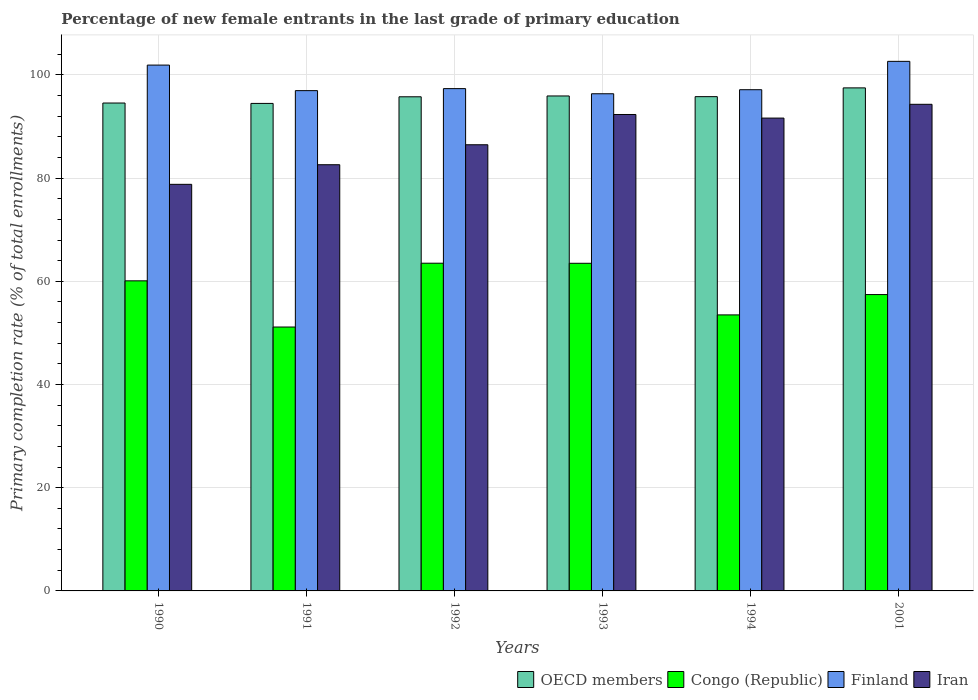Are the number of bars on each tick of the X-axis equal?
Provide a succinct answer. Yes. How many bars are there on the 5th tick from the right?
Ensure brevity in your answer.  4. In how many cases, is the number of bars for a given year not equal to the number of legend labels?
Provide a succinct answer. 0. What is the percentage of new female entrants in Finland in 1994?
Ensure brevity in your answer.  97.13. Across all years, what is the maximum percentage of new female entrants in Congo (Republic)?
Offer a terse response. 63.51. Across all years, what is the minimum percentage of new female entrants in Congo (Republic)?
Offer a very short reply. 51.14. What is the total percentage of new female entrants in OECD members in the graph?
Make the answer very short. 573.97. What is the difference between the percentage of new female entrants in Iran in 1990 and that in 1992?
Make the answer very short. -7.67. What is the difference between the percentage of new female entrants in Finland in 1993 and the percentage of new female entrants in Iran in 1991?
Make the answer very short. 13.75. What is the average percentage of new female entrants in Congo (Republic) per year?
Your answer should be very brief. 58.19. In the year 1991, what is the difference between the percentage of new female entrants in Iran and percentage of new female entrants in Congo (Republic)?
Keep it short and to the point. 31.45. What is the ratio of the percentage of new female entrants in Congo (Republic) in 1991 to that in 1993?
Ensure brevity in your answer.  0.81. Is the difference between the percentage of new female entrants in Iran in 1992 and 2001 greater than the difference between the percentage of new female entrants in Congo (Republic) in 1992 and 2001?
Ensure brevity in your answer.  No. What is the difference between the highest and the second highest percentage of new female entrants in Congo (Republic)?
Provide a succinct answer. 0.02. What is the difference between the highest and the lowest percentage of new female entrants in Congo (Republic)?
Keep it short and to the point. 12.36. Is the sum of the percentage of new female entrants in Finland in 1990 and 1994 greater than the maximum percentage of new female entrants in Congo (Republic) across all years?
Keep it short and to the point. Yes. What does the 2nd bar from the right in 1990 represents?
Make the answer very short. Finland. Are all the bars in the graph horizontal?
Your answer should be very brief. No. How many years are there in the graph?
Offer a terse response. 6. What is the difference between two consecutive major ticks on the Y-axis?
Your response must be concise. 20. Are the values on the major ticks of Y-axis written in scientific E-notation?
Provide a short and direct response. No. Does the graph contain any zero values?
Provide a succinct answer. No. Where does the legend appear in the graph?
Provide a succinct answer. Bottom right. How are the legend labels stacked?
Make the answer very short. Horizontal. What is the title of the graph?
Your answer should be compact. Percentage of new female entrants in the last grade of primary education. What is the label or title of the Y-axis?
Offer a terse response. Primary completion rate (% of total enrollments). What is the Primary completion rate (% of total enrollments) of OECD members in 1990?
Your response must be concise. 94.55. What is the Primary completion rate (% of total enrollments) in Congo (Republic) in 1990?
Your answer should be very brief. 60.09. What is the Primary completion rate (% of total enrollments) in Finland in 1990?
Ensure brevity in your answer.  101.9. What is the Primary completion rate (% of total enrollments) in Iran in 1990?
Your response must be concise. 78.79. What is the Primary completion rate (% of total enrollments) in OECD members in 1991?
Provide a succinct answer. 94.47. What is the Primary completion rate (% of total enrollments) of Congo (Republic) in 1991?
Provide a short and direct response. 51.14. What is the Primary completion rate (% of total enrollments) of Finland in 1991?
Offer a very short reply. 96.95. What is the Primary completion rate (% of total enrollments) in Iran in 1991?
Offer a very short reply. 82.59. What is the Primary completion rate (% of total enrollments) in OECD members in 1992?
Provide a succinct answer. 95.76. What is the Primary completion rate (% of total enrollments) in Congo (Republic) in 1992?
Your answer should be very brief. 63.51. What is the Primary completion rate (% of total enrollments) in Finland in 1992?
Your answer should be compact. 97.34. What is the Primary completion rate (% of total enrollments) in Iran in 1992?
Provide a short and direct response. 86.46. What is the Primary completion rate (% of total enrollments) of OECD members in 1993?
Your answer should be very brief. 95.92. What is the Primary completion rate (% of total enrollments) in Congo (Republic) in 1993?
Provide a succinct answer. 63.49. What is the Primary completion rate (% of total enrollments) in Finland in 1993?
Your answer should be very brief. 96.35. What is the Primary completion rate (% of total enrollments) of Iran in 1993?
Give a very brief answer. 92.33. What is the Primary completion rate (% of total enrollments) of OECD members in 1994?
Make the answer very short. 95.79. What is the Primary completion rate (% of total enrollments) in Congo (Republic) in 1994?
Offer a terse response. 53.49. What is the Primary completion rate (% of total enrollments) of Finland in 1994?
Your answer should be compact. 97.13. What is the Primary completion rate (% of total enrollments) of Iran in 1994?
Your answer should be very brief. 91.63. What is the Primary completion rate (% of total enrollments) in OECD members in 2001?
Offer a terse response. 97.48. What is the Primary completion rate (% of total enrollments) of Congo (Republic) in 2001?
Provide a succinct answer. 57.43. What is the Primary completion rate (% of total enrollments) in Finland in 2001?
Make the answer very short. 102.62. What is the Primary completion rate (% of total enrollments) of Iran in 2001?
Keep it short and to the point. 94.3. Across all years, what is the maximum Primary completion rate (% of total enrollments) of OECD members?
Make the answer very short. 97.48. Across all years, what is the maximum Primary completion rate (% of total enrollments) in Congo (Republic)?
Your answer should be very brief. 63.51. Across all years, what is the maximum Primary completion rate (% of total enrollments) of Finland?
Provide a short and direct response. 102.62. Across all years, what is the maximum Primary completion rate (% of total enrollments) in Iran?
Offer a terse response. 94.3. Across all years, what is the minimum Primary completion rate (% of total enrollments) in OECD members?
Keep it short and to the point. 94.47. Across all years, what is the minimum Primary completion rate (% of total enrollments) in Congo (Republic)?
Provide a succinct answer. 51.14. Across all years, what is the minimum Primary completion rate (% of total enrollments) of Finland?
Provide a short and direct response. 96.35. Across all years, what is the minimum Primary completion rate (% of total enrollments) in Iran?
Give a very brief answer. 78.79. What is the total Primary completion rate (% of total enrollments) of OECD members in the graph?
Your answer should be compact. 573.97. What is the total Primary completion rate (% of total enrollments) of Congo (Republic) in the graph?
Provide a succinct answer. 349.15. What is the total Primary completion rate (% of total enrollments) in Finland in the graph?
Give a very brief answer. 592.29. What is the total Primary completion rate (% of total enrollments) of Iran in the graph?
Provide a succinct answer. 526.11. What is the difference between the Primary completion rate (% of total enrollments) in OECD members in 1990 and that in 1991?
Keep it short and to the point. 0.08. What is the difference between the Primary completion rate (% of total enrollments) in Congo (Republic) in 1990 and that in 1991?
Your response must be concise. 8.95. What is the difference between the Primary completion rate (% of total enrollments) of Finland in 1990 and that in 1991?
Keep it short and to the point. 4.95. What is the difference between the Primary completion rate (% of total enrollments) in Iran in 1990 and that in 1991?
Provide a succinct answer. -3.8. What is the difference between the Primary completion rate (% of total enrollments) of OECD members in 1990 and that in 1992?
Ensure brevity in your answer.  -1.21. What is the difference between the Primary completion rate (% of total enrollments) in Congo (Republic) in 1990 and that in 1992?
Your answer should be compact. -3.41. What is the difference between the Primary completion rate (% of total enrollments) in Finland in 1990 and that in 1992?
Provide a short and direct response. 4.56. What is the difference between the Primary completion rate (% of total enrollments) of Iran in 1990 and that in 1992?
Make the answer very short. -7.67. What is the difference between the Primary completion rate (% of total enrollments) of OECD members in 1990 and that in 1993?
Provide a short and direct response. -1.37. What is the difference between the Primary completion rate (% of total enrollments) in Congo (Republic) in 1990 and that in 1993?
Ensure brevity in your answer.  -3.4. What is the difference between the Primary completion rate (% of total enrollments) of Finland in 1990 and that in 1993?
Offer a terse response. 5.56. What is the difference between the Primary completion rate (% of total enrollments) of Iran in 1990 and that in 1993?
Make the answer very short. -13.53. What is the difference between the Primary completion rate (% of total enrollments) of OECD members in 1990 and that in 1994?
Your answer should be very brief. -1.24. What is the difference between the Primary completion rate (% of total enrollments) of Congo (Republic) in 1990 and that in 1994?
Provide a short and direct response. 6.6. What is the difference between the Primary completion rate (% of total enrollments) of Finland in 1990 and that in 1994?
Provide a succinct answer. 4.77. What is the difference between the Primary completion rate (% of total enrollments) of Iran in 1990 and that in 1994?
Provide a succinct answer. -12.84. What is the difference between the Primary completion rate (% of total enrollments) in OECD members in 1990 and that in 2001?
Offer a terse response. -2.93. What is the difference between the Primary completion rate (% of total enrollments) of Congo (Republic) in 1990 and that in 2001?
Make the answer very short. 2.66. What is the difference between the Primary completion rate (% of total enrollments) in Finland in 1990 and that in 2001?
Your response must be concise. -0.72. What is the difference between the Primary completion rate (% of total enrollments) of Iran in 1990 and that in 2001?
Provide a succinct answer. -15.51. What is the difference between the Primary completion rate (% of total enrollments) of OECD members in 1991 and that in 1992?
Your response must be concise. -1.28. What is the difference between the Primary completion rate (% of total enrollments) in Congo (Republic) in 1991 and that in 1992?
Offer a terse response. -12.36. What is the difference between the Primary completion rate (% of total enrollments) in Finland in 1991 and that in 1992?
Ensure brevity in your answer.  -0.39. What is the difference between the Primary completion rate (% of total enrollments) in Iran in 1991 and that in 1992?
Keep it short and to the point. -3.87. What is the difference between the Primary completion rate (% of total enrollments) of OECD members in 1991 and that in 1993?
Make the answer very short. -1.44. What is the difference between the Primary completion rate (% of total enrollments) in Congo (Republic) in 1991 and that in 1993?
Give a very brief answer. -12.35. What is the difference between the Primary completion rate (% of total enrollments) of Finland in 1991 and that in 1993?
Provide a succinct answer. 0.6. What is the difference between the Primary completion rate (% of total enrollments) in Iran in 1991 and that in 1993?
Your answer should be very brief. -9.74. What is the difference between the Primary completion rate (% of total enrollments) of OECD members in 1991 and that in 1994?
Your answer should be very brief. -1.31. What is the difference between the Primary completion rate (% of total enrollments) in Congo (Republic) in 1991 and that in 1994?
Make the answer very short. -2.35. What is the difference between the Primary completion rate (% of total enrollments) of Finland in 1991 and that in 1994?
Your answer should be compact. -0.18. What is the difference between the Primary completion rate (% of total enrollments) in Iran in 1991 and that in 1994?
Keep it short and to the point. -9.04. What is the difference between the Primary completion rate (% of total enrollments) in OECD members in 1991 and that in 2001?
Your answer should be very brief. -3.01. What is the difference between the Primary completion rate (% of total enrollments) of Congo (Republic) in 1991 and that in 2001?
Offer a terse response. -6.29. What is the difference between the Primary completion rate (% of total enrollments) of Finland in 1991 and that in 2001?
Offer a terse response. -5.67. What is the difference between the Primary completion rate (% of total enrollments) in Iran in 1991 and that in 2001?
Your answer should be compact. -11.71. What is the difference between the Primary completion rate (% of total enrollments) of OECD members in 1992 and that in 1993?
Keep it short and to the point. -0.16. What is the difference between the Primary completion rate (% of total enrollments) of Congo (Republic) in 1992 and that in 1993?
Ensure brevity in your answer.  0.02. What is the difference between the Primary completion rate (% of total enrollments) of Finland in 1992 and that in 1993?
Give a very brief answer. 0.99. What is the difference between the Primary completion rate (% of total enrollments) of Iran in 1992 and that in 1993?
Offer a terse response. -5.87. What is the difference between the Primary completion rate (% of total enrollments) of OECD members in 1992 and that in 1994?
Your response must be concise. -0.03. What is the difference between the Primary completion rate (% of total enrollments) in Congo (Republic) in 1992 and that in 1994?
Keep it short and to the point. 10.02. What is the difference between the Primary completion rate (% of total enrollments) in Finland in 1992 and that in 1994?
Offer a terse response. 0.21. What is the difference between the Primary completion rate (% of total enrollments) of Iran in 1992 and that in 1994?
Offer a very short reply. -5.17. What is the difference between the Primary completion rate (% of total enrollments) of OECD members in 1992 and that in 2001?
Provide a short and direct response. -1.73. What is the difference between the Primary completion rate (% of total enrollments) in Congo (Republic) in 1992 and that in 2001?
Keep it short and to the point. 6.07. What is the difference between the Primary completion rate (% of total enrollments) of Finland in 1992 and that in 2001?
Make the answer very short. -5.28. What is the difference between the Primary completion rate (% of total enrollments) in Iran in 1992 and that in 2001?
Ensure brevity in your answer.  -7.84. What is the difference between the Primary completion rate (% of total enrollments) in OECD members in 1993 and that in 1994?
Give a very brief answer. 0.13. What is the difference between the Primary completion rate (% of total enrollments) in Congo (Republic) in 1993 and that in 1994?
Provide a succinct answer. 10. What is the difference between the Primary completion rate (% of total enrollments) of Finland in 1993 and that in 1994?
Keep it short and to the point. -0.78. What is the difference between the Primary completion rate (% of total enrollments) of Iran in 1993 and that in 1994?
Offer a very short reply. 0.7. What is the difference between the Primary completion rate (% of total enrollments) in OECD members in 1993 and that in 2001?
Your response must be concise. -1.57. What is the difference between the Primary completion rate (% of total enrollments) in Congo (Republic) in 1993 and that in 2001?
Give a very brief answer. 6.06. What is the difference between the Primary completion rate (% of total enrollments) of Finland in 1993 and that in 2001?
Your answer should be very brief. -6.28. What is the difference between the Primary completion rate (% of total enrollments) of Iran in 1993 and that in 2001?
Make the answer very short. -1.97. What is the difference between the Primary completion rate (% of total enrollments) of OECD members in 1994 and that in 2001?
Your answer should be very brief. -1.7. What is the difference between the Primary completion rate (% of total enrollments) of Congo (Republic) in 1994 and that in 2001?
Give a very brief answer. -3.94. What is the difference between the Primary completion rate (% of total enrollments) of Finland in 1994 and that in 2001?
Your response must be concise. -5.5. What is the difference between the Primary completion rate (% of total enrollments) in Iran in 1994 and that in 2001?
Provide a succinct answer. -2.67. What is the difference between the Primary completion rate (% of total enrollments) of OECD members in 1990 and the Primary completion rate (% of total enrollments) of Congo (Republic) in 1991?
Your response must be concise. 43.41. What is the difference between the Primary completion rate (% of total enrollments) in OECD members in 1990 and the Primary completion rate (% of total enrollments) in Finland in 1991?
Your answer should be very brief. -2.4. What is the difference between the Primary completion rate (% of total enrollments) of OECD members in 1990 and the Primary completion rate (% of total enrollments) of Iran in 1991?
Your answer should be compact. 11.96. What is the difference between the Primary completion rate (% of total enrollments) in Congo (Republic) in 1990 and the Primary completion rate (% of total enrollments) in Finland in 1991?
Offer a terse response. -36.86. What is the difference between the Primary completion rate (% of total enrollments) of Congo (Republic) in 1990 and the Primary completion rate (% of total enrollments) of Iran in 1991?
Offer a terse response. -22.5. What is the difference between the Primary completion rate (% of total enrollments) in Finland in 1990 and the Primary completion rate (% of total enrollments) in Iran in 1991?
Keep it short and to the point. 19.31. What is the difference between the Primary completion rate (% of total enrollments) of OECD members in 1990 and the Primary completion rate (% of total enrollments) of Congo (Republic) in 1992?
Provide a short and direct response. 31.04. What is the difference between the Primary completion rate (% of total enrollments) in OECD members in 1990 and the Primary completion rate (% of total enrollments) in Finland in 1992?
Provide a short and direct response. -2.79. What is the difference between the Primary completion rate (% of total enrollments) of OECD members in 1990 and the Primary completion rate (% of total enrollments) of Iran in 1992?
Your answer should be compact. 8.09. What is the difference between the Primary completion rate (% of total enrollments) in Congo (Republic) in 1990 and the Primary completion rate (% of total enrollments) in Finland in 1992?
Offer a terse response. -37.25. What is the difference between the Primary completion rate (% of total enrollments) of Congo (Republic) in 1990 and the Primary completion rate (% of total enrollments) of Iran in 1992?
Keep it short and to the point. -26.37. What is the difference between the Primary completion rate (% of total enrollments) in Finland in 1990 and the Primary completion rate (% of total enrollments) in Iran in 1992?
Offer a terse response. 15.44. What is the difference between the Primary completion rate (% of total enrollments) in OECD members in 1990 and the Primary completion rate (% of total enrollments) in Congo (Republic) in 1993?
Keep it short and to the point. 31.06. What is the difference between the Primary completion rate (% of total enrollments) in OECD members in 1990 and the Primary completion rate (% of total enrollments) in Finland in 1993?
Offer a very short reply. -1.8. What is the difference between the Primary completion rate (% of total enrollments) in OECD members in 1990 and the Primary completion rate (% of total enrollments) in Iran in 1993?
Your answer should be very brief. 2.22. What is the difference between the Primary completion rate (% of total enrollments) of Congo (Republic) in 1990 and the Primary completion rate (% of total enrollments) of Finland in 1993?
Make the answer very short. -36.26. What is the difference between the Primary completion rate (% of total enrollments) of Congo (Republic) in 1990 and the Primary completion rate (% of total enrollments) of Iran in 1993?
Your response must be concise. -32.24. What is the difference between the Primary completion rate (% of total enrollments) in Finland in 1990 and the Primary completion rate (% of total enrollments) in Iran in 1993?
Your response must be concise. 9.57. What is the difference between the Primary completion rate (% of total enrollments) of OECD members in 1990 and the Primary completion rate (% of total enrollments) of Congo (Republic) in 1994?
Keep it short and to the point. 41.06. What is the difference between the Primary completion rate (% of total enrollments) in OECD members in 1990 and the Primary completion rate (% of total enrollments) in Finland in 1994?
Your response must be concise. -2.58. What is the difference between the Primary completion rate (% of total enrollments) of OECD members in 1990 and the Primary completion rate (% of total enrollments) of Iran in 1994?
Your answer should be very brief. 2.92. What is the difference between the Primary completion rate (% of total enrollments) of Congo (Republic) in 1990 and the Primary completion rate (% of total enrollments) of Finland in 1994?
Provide a succinct answer. -37.04. What is the difference between the Primary completion rate (% of total enrollments) in Congo (Republic) in 1990 and the Primary completion rate (% of total enrollments) in Iran in 1994?
Offer a terse response. -31.54. What is the difference between the Primary completion rate (% of total enrollments) of Finland in 1990 and the Primary completion rate (% of total enrollments) of Iran in 1994?
Give a very brief answer. 10.27. What is the difference between the Primary completion rate (% of total enrollments) of OECD members in 1990 and the Primary completion rate (% of total enrollments) of Congo (Republic) in 2001?
Offer a very short reply. 37.12. What is the difference between the Primary completion rate (% of total enrollments) of OECD members in 1990 and the Primary completion rate (% of total enrollments) of Finland in 2001?
Ensure brevity in your answer.  -8.07. What is the difference between the Primary completion rate (% of total enrollments) in OECD members in 1990 and the Primary completion rate (% of total enrollments) in Iran in 2001?
Your answer should be compact. 0.25. What is the difference between the Primary completion rate (% of total enrollments) in Congo (Republic) in 1990 and the Primary completion rate (% of total enrollments) in Finland in 2001?
Give a very brief answer. -42.53. What is the difference between the Primary completion rate (% of total enrollments) of Congo (Republic) in 1990 and the Primary completion rate (% of total enrollments) of Iran in 2001?
Your response must be concise. -34.21. What is the difference between the Primary completion rate (% of total enrollments) in Finland in 1990 and the Primary completion rate (% of total enrollments) in Iran in 2001?
Offer a terse response. 7.6. What is the difference between the Primary completion rate (% of total enrollments) of OECD members in 1991 and the Primary completion rate (% of total enrollments) of Congo (Republic) in 1992?
Make the answer very short. 30.97. What is the difference between the Primary completion rate (% of total enrollments) of OECD members in 1991 and the Primary completion rate (% of total enrollments) of Finland in 1992?
Provide a short and direct response. -2.87. What is the difference between the Primary completion rate (% of total enrollments) in OECD members in 1991 and the Primary completion rate (% of total enrollments) in Iran in 1992?
Ensure brevity in your answer.  8.01. What is the difference between the Primary completion rate (% of total enrollments) in Congo (Republic) in 1991 and the Primary completion rate (% of total enrollments) in Finland in 1992?
Your response must be concise. -46.2. What is the difference between the Primary completion rate (% of total enrollments) of Congo (Republic) in 1991 and the Primary completion rate (% of total enrollments) of Iran in 1992?
Provide a short and direct response. -35.32. What is the difference between the Primary completion rate (% of total enrollments) in Finland in 1991 and the Primary completion rate (% of total enrollments) in Iran in 1992?
Your answer should be compact. 10.49. What is the difference between the Primary completion rate (% of total enrollments) of OECD members in 1991 and the Primary completion rate (% of total enrollments) of Congo (Republic) in 1993?
Ensure brevity in your answer.  30.98. What is the difference between the Primary completion rate (% of total enrollments) of OECD members in 1991 and the Primary completion rate (% of total enrollments) of Finland in 1993?
Give a very brief answer. -1.87. What is the difference between the Primary completion rate (% of total enrollments) of OECD members in 1991 and the Primary completion rate (% of total enrollments) of Iran in 1993?
Give a very brief answer. 2.14. What is the difference between the Primary completion rate (% of total enrollments) in Congo (Republic) in 1991 and the Primary completion rate (% of total enrollments) in Finland in 1993?
Provide a succinct answer. -45.2. What is the difference between the Primary completion rate (% of total enrollments) in Congo (Republic) in 1991 and the Primary completion rate (% of total enrollments) in Iran in 1993?
Your response must be concise. -41.19. What is the difference between the Primary completion rate (% of total enrollments) in Finland in 1991 and the Primary completion rate (% of total enrollments) in Iran in 1993?
Offer a terse response. 4.62. What is the difference between the Primary completion rate (% of total enrollments) in OECD members in 1991 and the Primary completion rate (% of total enrollments) in Congo (Republic) in 1994?
Your answer should be compact. 40.98. What is the difference between the Primary completion rate (% of total enrollments) in OECD members in 1991 and the Primary completion rate (% of total enrollments) in Finland in 1994?
Your answer should be very brief. -2.66. What is the difference between the Primary completion rate (% of total enrollments) of OECD members in 1991 and the Primary completion rate (% of total enrollments) of Iran in 1994?
Ensure brevity in your answer.  2.84. What is the difference between the Primary completion rate (% of total enrollments) in Congo (Republic) in 1991 and the Primary completion rate (% of total enrollments) in Finland in 1994?
Your answer should be compact. -45.99. What is the difference between the Primary completion rate (% of total enrollments) of Congo (Republic) in 1991 and the Primary completion rate (% of total enrollments) of Iran in 1994?
Keep it short and to the point. -40.49. What is the difference between the Primary completion rate (% of total enrollments) in Finland in 1991 and the Primary completion rate (% of total enrollments) in Iran in 1994?
Your response must be concise. 5.32. What is the difference between the Primary completion rate (% of total enrollments) of OECD members in 1991 and the Primary completion rate (% of total enrollments) of Congo (Republic) in 2001?
Your answer should be very brief. 37.04. What is the difference between the Primary completion rate (% of total enrollments) in OECD members in 1991 and the Primary completion rate (% of total enrollments) in Finland in 2001?
Your answer should be compact. -8.15. What is the difference between the Primary completion rate (% of total enrollments) of OECD members in 1991 and the Primary completion rate (% of total enrollments) of Iran in 2001?
Keep it short and to the point. 0.17. What is the difference between the Primary completion rate (% of total enrollments) of Congo (Republic) in 1991 and the Primary completion rate (% of total enrollments) of Finland in 2001?
Provide a succinct answer. -51.48. What is the difference between the Primary completion rate (% of total enrollments) in Congo (Republic) in 1991 and the Primary completion rate (% of total enrollments) in Iran in 2001?
Keep it short and to the point. -43.16. What is the difference between the Primary completion rate (% of total enrollments) of Finland in 1991 and the Primary completion rate (% of total enrollments) of Iran in 2001?
Make the answer very short. 2.65. What is the difference between the Primary completion rate (% of total enrollments) in OECD members in 1992 and the Primary completion rate (% of total enrollments) in Congo (Republic) in 1993?
Give a very brief answer. 32.27. What is the difference between the Primary completion rate (% of total enrollments) of OECD members in 1992 and the Primary completion rate (% of total enrollments) of Finland in 1993?
Provide a short and direct response. -0.59. What is the difference between the Primary completion rate (% of total enrollments) in OECD members in 1992 and the Primary completion rate (% of total enrollments) in Iran in 1993?
Provide a succinct answer. 3.43. What is the difference between the Primary completion rate (% of total enrollments) in Congo (Republic) in 1992 and the Primary completion rate (% of total enrollments) in Finland in 1993?
Offer a terse response. -32.84. What is the difference between the Primary completion rate (% of total enrollments) in Congo (Republic) in 1992 and the Primary completion rate (% of total enrollments) in Iran in 1993?
Make the answer very short. -28.82. What is the difference between the Primary completion rate (% of total enrollments) of Finland in 1992 and the Primary completion rate (% of total enrollments) of Iran in 1993?
Make the answer very short. 5.01. What is the difference between the Primary completion rate (% of total enrollments) of OECD members in 1992 and the Primary completion rate (% of total enrollments) of Congo (Republic) in 1994?
Your answer should be compact. 42.27. What is the difference between the Primary completion rate (% of total enrollments) in OECD members in 1992 and the Primary completion rate (% of total enrollments) in Finland in 1994?
Make the answer very short. -1.37. What is the difference between the Primary completion rate (% of total enrollments) of OECD members in 1992 and the Primary completion rate (% of total enrollments) of Iran in 1994?
Offer a very short reply. 4.13. What is the difference between the Primary completion rate (% of total enrollments) in Congo (Republic) in 1992 and the Primary completion rate (% of total enrollments) in Finland in 1994?
Offer a very short reply. -33.62. What is the difference between the Primary completion rate (% of total enrollments) of Congo (Republic) in 1992 and the Primary completion rate (% of total enrollments) of Iran in 1994?
Your response must be concise. -28.12. What is the difference between the Primary completion rate (% of total enrollments) in Finland in 1992 and the Primary completion rate (% of total enrollments) in Iran in 1994?
Ensure brevity in your answer.  5.71. What is the difference between the Primary completion rate (% of total enrollments) in OECD members in 1992 and the Primary completion rate (% of total enrollments) in Congo (Republic) in 2001?
Make the answer very short. 38.33. What is the difference between the Primary completion rate (% of total enrollments) of OECD members in 1992 and the Primary completion rate (% of total enrollments) of Finland in 2001?
Keep it short and to the point. -6.87. What is the difference between the Primary completion rate (% of total enrollments) in OECD members in 1992 and the Primary completion rate (% of total enrollments) in Iran in 2001?
Make the answer very short. 1.45. What is the difference between the Primary completion rate (% of total enrollments) of Congo (Republic) in 1992 and the Primary completion rate (% of total enrollments) of Finland in 2001?
Provide a short and direct response. -39.12. What is the difference between the Primary completion rate (% of total enrollments) in Congo (Republic) in 1992 and the Primary completion rate (% of total enrollments) in Iran in 2001?
Provide a short and direct response. -30.8. What is the difference between the Primary completion rate (% of total enrollments) in Finland in 1992 and the Primary completion rate (% of total enrollments) in Iran in 2001?
Provide a succinct answer. 3.04. What is the difference between the Primary completion rate (% of total enrollments) in OECD members in 1993 and the Primary completion rate (% of total enrollments) in Congo (Republic) in 1994?
Ensure brevity in your answer.  42.43. What is the difference between the Primary completion rate (% of total enrollments) of OECD members in 1993 and the Primary completion rate (% of total enrollments) of Finland in 1994?
Your response must be concise. -1.21. What is the difference between the Primary completion rate (% of total enrollments) in OECD members in 1993 and the Primary completion rate (% of total enrollments) in Iran in 1994?
Your response must be concise. 4.29. What is the difference between the Primary completion rate (% of total enrollments) of Congo (Republic) in 1993 and the Primary completion rate (% of total enrollments) of Finland in 1994?
Provide a succinct answer. -33.64. What is the difference between the Primary completion rate (% of total enrollments) in Congo (Republic) in 1993 and the Primary completion rate (% of total enrollments) in Iran in 1994?
Your answer should be very brief. -28.14. What is the difference between the Primary completion rate (% of total enrollments) in Finland in 1993 and the Primary completion rate (% of total enrollments) in Iran in 1994?
Offer a very short reply. 4.72. What is the difference between the Primary completion rate (% of total enrollments) of OECD members in 1993 and the Primary completion rate (% of total enrollments) of Congo (Republic) in 2001?
Give a very brief answer. 38.49. What is the difference between the Primary completion rate (% of total enrollments) in OECD members in 1993 and the Primary completion rate (% of total enrollments) in Finland in 2001?
Your answer should be compact. -6.71. What is the difference between the Primary completion rate (% of total enrollments) in OECD members in 1993 and the Primary completion rate (% of total enrollments) in Iran in 2001?
Offer a terse response. 1.61. What is the difference between the Primary completion rate (% of total enrollments) of Congo (Republic) in 1993 and the Primary completion rate (% of total enrollments) of Finland in 2001?
Give a very brief answer. -39.13. What is the difference between the Primary completion rate (% of total enrollments) in Congo (Republic) in 1993 and the Primary completion rate (% of total enrollments) in Iran in 2001?
Make the answer very short. -30.81. What is the difference between the Primary completion rate (% of total enrollments) in Finland in 1993 and the Primary completion rate (% of total enrollments) in Iran in 2001?
Offer a terse response. 2.04. What is the difference between the Primary completion rate (% of total enrollments) of OECD members in 1994 and the Primary completion rate (% of total enrollments) of Congo (Republic) in 2001?
Provide a succinct answer. 38.35. What is the difference between the Primary completion rate (% of total enrollments) of OECD members in 1994 and the Primary completion rate (% of total enrollments) of Finland in 2001?
Your answer should be compact. -6.84. What is the difference between the Primary completion rate (% of total enrollments) of OECD members in 1994 and the Primary completion rate (% of total enrollments) of Iran in 2001?
Your answer should be compact. 1.48. What is the difference between the Primary completion rate (% of total enrollments) of Congo (Republic) in 1994 and the Primary completion rate (% of total enrollments) of Finland in 2001?
Your answer should be compact. -49.13. What is the difference between the Primary completion rate (% of total enrollments) of Congo (Republic) in 1994 and the Primary completion rate (% of total enrollments) of Iran in 2001?
Your response must be concise. -40.81. What is the difference between the Primary completion rate (% of total enrollments) of Finland in 1994 and the Primary completion rate (% of total enrollments) of Iran in 2001?
Keep it short and to the point. 2.83. What is the average Primary completion rate (% of total enrollments) of OECD members per year?
Provide a succinct answer. 95.66. What is the average Primary completion rate (% of total enrollments) of Congo (Republic) per year?
Your answer should be compact. 58.19. What is the average Primary completion rate (% of total enrollments) of Finland per year?
Give a very brief answer. 98.72. What is the average Primary completion rate (% of total enrollments) in Iran per year?
Provide a succinct answer. 87.69. In the year 1990, what is the difference between the Primary completion rate (% of total enrollments) in OECD members and Primary completion rate (% of total enrollments) in Congo (Republic)?
Ensure brevity in your answer.  34.46. In the year 1990, what is the difference between the Primary completion rate (% of total enrollments) in OECD members and Primary completion rate (% of total enrollments) in Finland?
Your answer should be compact. -7.35. In the year 1990, what is the difference between the Primary completion rate (% of total enrollments) of OECD members and Primary completion rate (% of total enrollments) of Iran?
Make the answer very short. 15.76. In the year 1990, what is the difference between the Primary completion rate (% of total enrollments) of Congo (Republic) and Primary completion rate (% of total enrollments) of Finland?
Provide a short and direct response. -41.81. In the year 1990, what is the difference between the Primary completion rate (% of total enrollments) in Congo (Republic) and Primary completion rate (% of total enrollments) in Iran?
Keep it short and to the point. -18.7. In the year 1990, what is the difference between the Primary completion rate (% of total enrollments) of Finland and Primary completion rate (% of total enrollments) of Iran?
Provide a short and direct response. 23.11. In the year 1991, what is the difference between the Primary completion rate (% of total enrollments) in OECD members and Primary completion rate (% of total enrollments) in Congo (Republic)?
Provide a succinct answer. 43.33. In the year 1991, what is the difference between the Primary completion rate (% of total enrollments) in OECD members and Primary completion rate (% of total enrollments) in Finland?
Your answer should be compact. -2.48. In the year 1991, what is the difference between the Primary completion rate (% of total enrollments) in OECD members and Primary completion rate (% of total enrollments) in Iran?
Give a very brief answer. 11.88. In the year 1991, what is the difference between the Primary completion rate (% of total enrollments) of Congo (Republic) and Primary completion rate (% of total enrollments) of Finland?
Provide a short and direct response. -45.81. In the year 1991, what is the difference between the Primary completion rate (% of total enrollments) of Congo (Republic) and Primary completion rate (% of total enrollments) of Iran?
Ensure brevity in your answer.  -31.45. In the year 1991, what is the difference between the Primary completion rate (% of total enrollments) in Finland and Primary completion rate (% of total enrollments) in Iran?
Your answer should be compact. 14.36. In the year 1992, what is the difference between the Primary completion rate (% of total enrollments) of OECD members and Primary completion rate (% of total enrollments) of Congo (Republic)?
Your answer should be very brief. 32.25. In the year 1992, what is the difference between the Primary completion rate (% of total enrollments) in OECD members and Primary completion rate (% of total enrollments) in Finland?
Your answer should be compact. -1.58. In the year 1992, what is the difference between the Primary completion rate (% of total enrollments) in OECD members and Primary completion rate (% of total enrollments) in Iran?
Offer a very short reply. 9.29. In the year 1992, what is the difference between the Primary completion rate (% of total enrollments) in Congo (Republic) and Primary completion rate (% of total enrollments) in Finland?
Make the answer very short. -33.83. In the year 1992, what is the difference between the Primary completion rate (% of total enrollments) in Congo (Republic) and Primary completion rate (% of total enrollments) in Iran?
Offer a very short reply. -22.96. In the year 1992, what is the difference between the Primary completion rate (% of total enrollments) in Finland and Primary completion rate (% of total enrollments) in Iran?
Your response must be concise. 10.88. In the year 1993, what is the difference between the Primary completion rate (% of total enrollments) in OECD members and Primary completion rate (% of total enrollments) in Congo (Republic)?
Your response must be concise. 32.43. In the year 1993, what is the difference between the Primary completion rate (% of total enrollments) of OECD members and Primary completion rate (% of total enrollments) of Finland?
Offer a very short reply. -0.43. In the year 1993, what is the difference between the Primary completion rate (% of total enrollments) in OECD members and Primary completion rate (% of total enrollments) in Iran?
Make the answer very short. 3.59. In the year 1993, what is the difference between the Primary completion rate (% of total enrollments) of Congo (Republic) and Primary completion rate (% of total enrollments) of Finland?
Ensure brevity in your answer.  -32.86. In the year 1993, what is the difference between the Primary completion rate (% of total enrollments) of Congo (Republic) and Primary completion rate (% of total enrollments) of Iran?
Keep it short and to the point. -28.84. In the year 1993, what is the difference between the Primary completion rate (% of total enrollments) of Finland and Primary completion rate (% of total enrollments) of Iran?
Make the answer very short. 4.02. In the year 1994, what is the difference between the Primary completion rate (% of total enrollments) of OECD members and Primary completion rate (% of total enrollments) of Congo (Republic)?
Your answer should be very brief. 42.3. In the year 1994, what is the difference between the Primary completion rate (% of total enrollments) in OECD members and Primary completion rate (% of total enrollments) in Finland?
Provide a succinct answer. -1.34. In the year 1994, what is the difference between the Primary completion rate (% of total enrollments) in OECD members and Primary completion rate (% of total enrollments) in Iran?
Make the answer very short. 4.16. In the year 1994, what is the difference between the Primary completion rate (% of total enrollments) of Congo (Republic) and Primary completion rate (% of total enrollments) of Finland?
Your response must be concise. -43.64. In the year 1994, what is the difference between the Primary completion rate (% of total enrollments) of Congo (Republic) and Primary completion rate (% of total enrollments) of Iran?
Provide a succinct answer. -38.14. In the year 1994, what is the difference between the Primary completion rate (% of total enrollments) of Finland and Primary completion rate (% of total enrollments) of Iran?
Your answer should be compact. 5.5. In the year 2001, what is the difference between the Primary completion rate (% of total enrollments) in OECD members and Primary completion rate (% of total enrollments) in Congo (Republic)?
Offer a very short reply. 40.05. In the year 2001, what is the difference between the Primary completion rate (% of total enrollments) in OECD members and Primary completion rate (% of total enrollments) in Finland?
Ensure brevity in your answer.  -5.14. In the year 2001, what is the difference between the Primary completion rate (% of total enrollments) of OECD members and Primary completion rate (% of total enrollments) of Iran?
Keep it short and to the point. 3.18. In the year 2001, what is the difference between the Primary completion rate (% of total enrollments) in Congo (Republic) and Primary completion rate (% of total enrollments) in Finland?
Offer a terse response. -45.19. In the year 2001, what is the difference between the Primary completion rate (% of total enrollments) in Congo (Republic) and Primary completion rate (% of total enrollments) in Iran?
Provide a short and direct response. -36.87. In the year 2001, what is the difference between the Primary completion rate (% of total enrollments) in Finland and Primary completion rate (% of total enrollments) in Iran?
Keep it short and to the point. 8.32. What is the ratio of the Primary completion rate (% of total enrollments) of OECD members in 1990 to that in 1991?
Provide a short and direct response. 1. What is the ratio of the Primary completion rate (% of total enrollments) of Congo (Republic) in 1990 to that in 1991?
Offer a terse response. 1.18. What is the ratio of the Primary completion rate (% of total enrollments) in Finland in 1990 to that in 1991?
Your answer should be very brief. 1.05. What is the ratio of the Primary completion rate (% of total enrollments) of Iran in 1990 to that in 1991?
Provide a succinct answer. 0.95. What is the ratio of the Primary completion rate (% of total enrollments) in OECD members in 1990 to that in 1992?
Provide a short and direct response. 0.99. What is the ratio of the Primary completion rate (% of total enrollments) of Congo (Republic) in 1990 to that in 1992?
Ensure brevity in your answer.  0.95. What is the ratio of the Primary completion rate (% of total enrollments) of Finland in 1990 to that in 1992?
Provide a short and direct response. 1.05. What is the ratio of the Primary completion rate (% of total enrollments) of Iran in 1990 to that in 1992?
Keep it short and to the point. 0.91. What is the ratio of the Primary completion rate (% of total enrollments) of OECD members in 1990 to that in 1993?
Provide a succinct answer. 0.99. What is the ratio of the Primary completion rate (% of total enrollments) of Congo (Republic) in 1990 to that in 1993?
Give a very brief answer. 0.95. What is the ratio of the Primary completion rate (% of total enrollments) of Finland in 1990 to that in 1993?
Your answer should be very brief. 1.06. What is the ratio of the Primary completion rate (% of total enrollments) of Iran in 1990 to that in 1993?
Offer a terse response. 0.85. What is the ratio of the Primary completion rate (% of total enrollments) in OECD members in 1990 to that in 1994?
Provide a short and direct response. 0.99. What is the ratio of the Primary completion rate (% of total enrollments) in Congo (Republic) in 1990 to that in 1994?
Provide a short and direct response. 1.12. What is the ratio of the Primary completion rate (% of total enrollments) of Finland in 1990 to that in 1994?
Provide a succinct answer. 1.05. What is the ratio of the Primary completion rate (% of total enrollments) of Iran in 1990 to that in 1994?
Your answer should be compact. 0.86. What is the ratio of the Primary completion rate (% of total enrollments) of OECD members in 1990 to that in 2001?
Your answer should be compact. 0.97. What is the ratio of the Primary completion rate (% of total enrollments) in Congo (Republic) in 1990 to that in 2001?
Provide a short and direct response. 1.05. What is the ratio of the Primary completion rate (% of total enrollments) in Finland in 1990 to that in 2001?
Your response must be concise. 0.99. What is the ratio of the Primary completion rate (% of total enrollments) in Iran in 1990 to that in 2001?
Give a very brief answer. 0.84. What is the ratio of the Primary completion rate (% of total enrollments) in OECD members in 1991 to that in 1992?
Provide a short and direct response. 0.99. What is the ratio of the Primary completion rate (% of total enrollments) in Congo (Republic) in 1991 to that in 1992?
Make the answer very short. 0.81. What is the ratio of the Primary completion rate (% of total enrollments) in Iran in 1991 to that in 1992?
Provide a succinct answer. 0.96. What is the ratio of the Primary completion rate (% of total enrollments) of OECD members in 1991 to that in 1993?
Offer a terse response. 0.98. What is the ratio of the Primary completion rate (% of total enrollments) in Congo (Republic) in 1991 to that in 1993?
Provide a short and direct response. 0.81. What is the ratio of the Primary completion rate (% of total enrollments) in Iran in 1991 to that in 1993?
Your answer should be compact. 0.89. What is the ratio of the Primary completion rate (% of total enrollments) in OECD members in 1991 to that in 1994?
Provide a short and direct response. 0.99. What is the ratio of the Primary completion rate (% of total enrollments) of Congo (Republic) in 1991 to that in 1994?
Offer a very short reply. 0.96. What is the ratio of the Primary completion rate (% of total enrollments) in Iran in 1991 to that in 1994?
Ensure brevity in your answer.  0.9. What is the ratio of the Primary completion rate (% of total enrollments) of OECD members in 1991 to that in 2001?
Your response must be concise. 0.97. What is the ratio of the Primary completion rate (% of total enrollments) in Congo (Republic) in 1991 to that in 2001?
Your response must be concise. 0.89. What is the ratio of the Primary completion rate (% of total enrollments) of Finland in 1991 to that in 2001?
Your answer should be very brief. 0.94. What is the ratio of the Primary completion rate (% of total enrollments) of Iran in 1991 to that in 2001?
Make the answer very short. 0.88. What is the ratio of the Primary completion rate (% of total enrollments) of OECD members in 1992 to that in 1993?
Ensure brevity in your answer.  1. What is the ratio of the Primary completion rate (% of total enrollments) in Congo (Republic) in 1992 to that in 1993?
Provide a short and direct response. 1. What is the ratio of the Primary completion rate (% of total enrollments) of Finland in 1992 to that in 1993?
Provide a short and direct response. 1.01. What is the ratio of the Primary completion rate (% of total enrollments) in Iran in 1992 to that in 1993?
Your answer should be compact. 0.94. What is the ratio of the Primary completion rate (% of total enrollments) in OECD members in 1992 to that in 1994?
Your response must be concise. 1. What is the ratio of the Primary completion rate (% of total enrollments) in Congo (Republic) in 1992 to that in 1994?
Make the answer very short. 1.19. What is the ratio of the Primary completion rate (% of total enrollments) in Finland in 1992 to that in 1994?
Your answer should be very brief. 1. What is the ratio of the Primary completion rate (% of total enrollments) of Iran in 1992 to that in 1994?
Provide a succinct answer. 0.94. What is the ratio of the Primary completion rate (% of total enrollments) in OECD members in 1992 to that in 2001?
Your answer should be compact. 0.98. What is the ratio of the Primary completion rate (% of total enrollments) in Congo (Republic) in 1992 to that in 2001?
Your response must be concise. 1.11. What is the ratio of the Primary completion rate (% of total enrollments) of Finland in 1992 to that in 2001?
Your answer should be very brief. 0.95. What is the ratio of the Primary completion rate (% of total enrollments) of Iran in 1992 to that in 2001?
Provide a short and direct response. 0.92. What is the ratio of the Primary completion rate (% of total enrollments) in OECD members in 1993 to that in 1994?
Provide a succinct answer. 1. What is the ratio of the Primary completion rate (% of total enrollments) of Congo (Republic) in 1993 to that in 1994?
Ensure brevity in your answer.  1.19. What is the ratio of the Primary completion rate (% of total enrollments) of Finland in 1993 to that in 1994?
Keep it short and to the point. 0.99. What is the ratio of the Primary completion rate (% of total enrollments) of Iran in 1993 to that in 1994?
Keep it short and to the point. 1.01. What is the ratio of the Primary completion rate (% of total enrollments) of OECD members in 1993 to that in 2001?
Provide a succinct answer. 0.98. What is the ratio of the Primary completion rate (% of total enrollments) in Congo (Republic) in 1993 to that in 2001?
Make the answer very short. 1.11. What is the ratio of the Primary completion rate (% of total enrollments) in Finland in 1993 to that in 2001?
Offer a very short reply. 0.94. What is the ratio of the Primary completion rate (% of total enrollments) of Iran in 1993 to that in 2001?
Give a very brief answer. 0.98. What is the ratio of the Primary completion rate (% of total enrollments) in OECD members in 1994 to that in 2001?
Your answer should be very brief. 0.98. What is the ratio of the Primary completion rate (% of total enrollments) of Congo (Republic) in 1994 to that in 2001?
Your answer should be very brief. 0.93. What is the ratio of the Primary completion rate (% of total enrollments) in Finland in 1994 to that in 2001?
Provide a short and direct response. 0.95. What is the ratio of the Primary completion rate (% of total enrollments) of Iran in 1994 to that in 2001?
Give a very brief answer. 0.97. What is the difference between the highest and the second highest Primary completion rate (% of total enrollments) of OECD members?
Give a very brief answer. 1.57. What is the difference between the highest and the second highest Primary completion rate (% of total enrollments) of Congo (Republic)?
Provide a short and direct response. 0.02. What is the difference between the highest and the second highest Primary completion rate (% of total enrollments) of Finland?
Provide a short and direct response. 0.72. What is the difference between the highest and the second highest Primary completion rate (% of total enrollments) in Iran?
Your answer should be compact. 1.97. What is the difference between the highest and the lowest Primary completion rate (% of total enrollments) of OECD members?
Provide a succinct answer. 3.01. What is the difference between the highest and the lowest Primary completion rate (% of total enrollments) of Congo (Republic)?
Ensure brevity in your answer.  12.36. What is the difference between the highest and the lowest Primary completion rate (% of total enrollments) of Finland?
Provide a short and direct response. 6.28. What is the difference between the highest and the lowest Primary completion rate (% of total enrollments) of Iran?
Give a very brief answer. 15.51. 